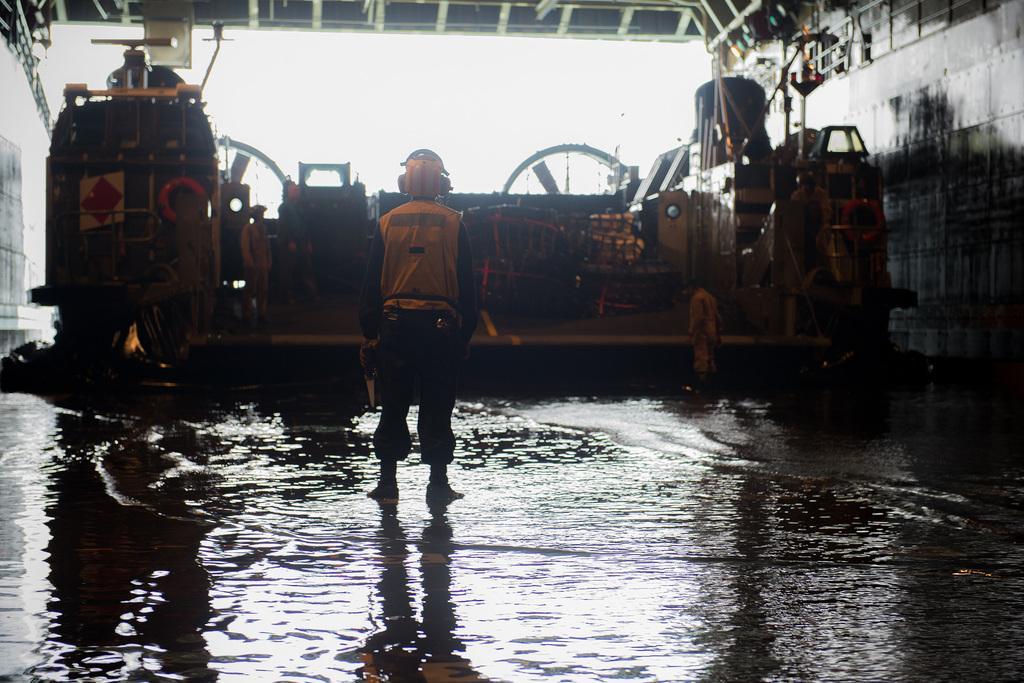Could you give a brief overview of what you see in this image? In this picture I can see group of people standing, there is water, this is looking like a vehicle, and there is shed. 